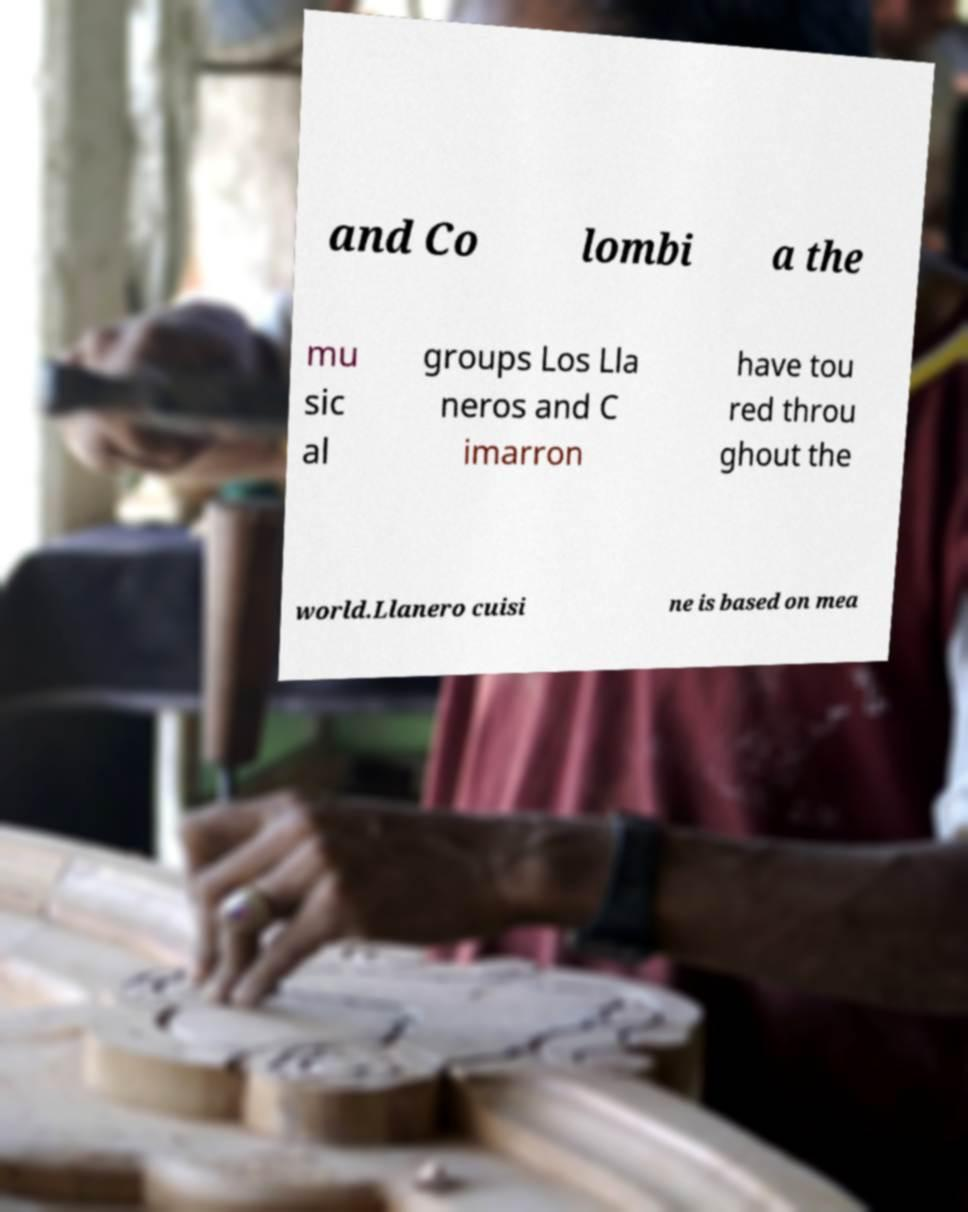Could you assist in decoding the text presented in this image and type it out clearly? and Co lombi a the mu sic al groups Los Lla neros and C imarron have tou red throu ghout the world.Llanero cuisi ne is based on mea 